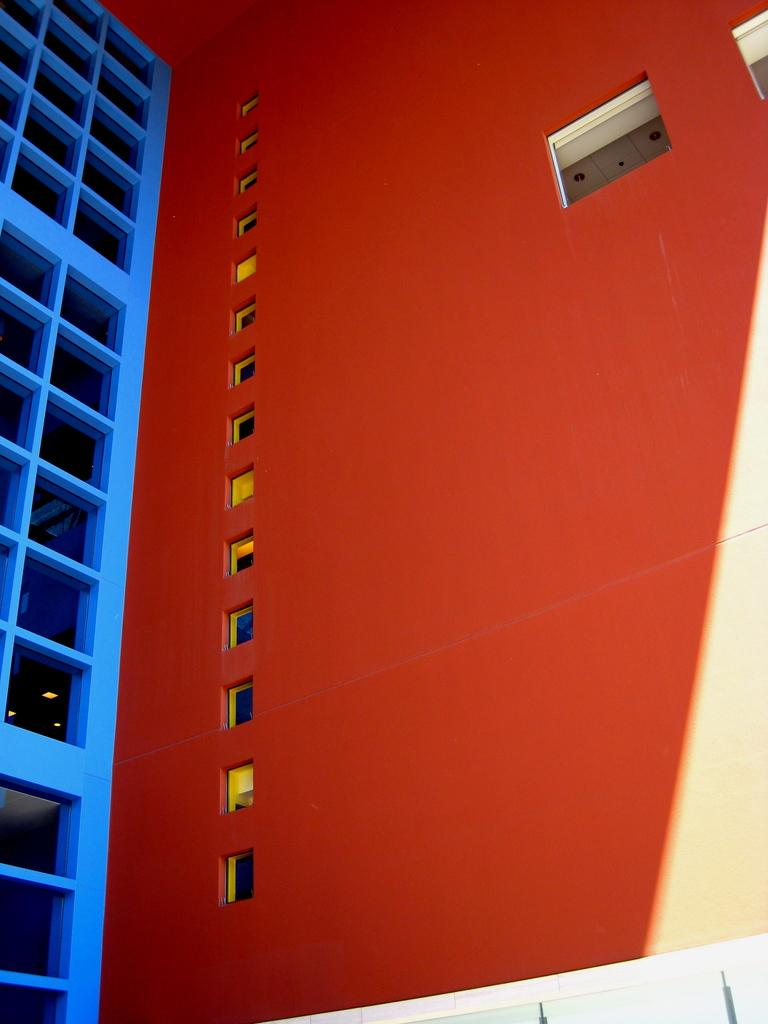What type of structure is present in the image? There is a tall wall in the image. What color is the tall wall? The tall wall is painted in orange color. How many windows are there on the tall wall? The tall wall has many windows. What can be seen on the left side of the image? There is a blue wall construction on the left side of the image. What is the shape of the blocks in the blue wall construction? The blue wall construction has square blocks. How does the dust settle on the tall wall in the image? There is no mention of dust in the image, so we cannot determine how it settles on the wall. 